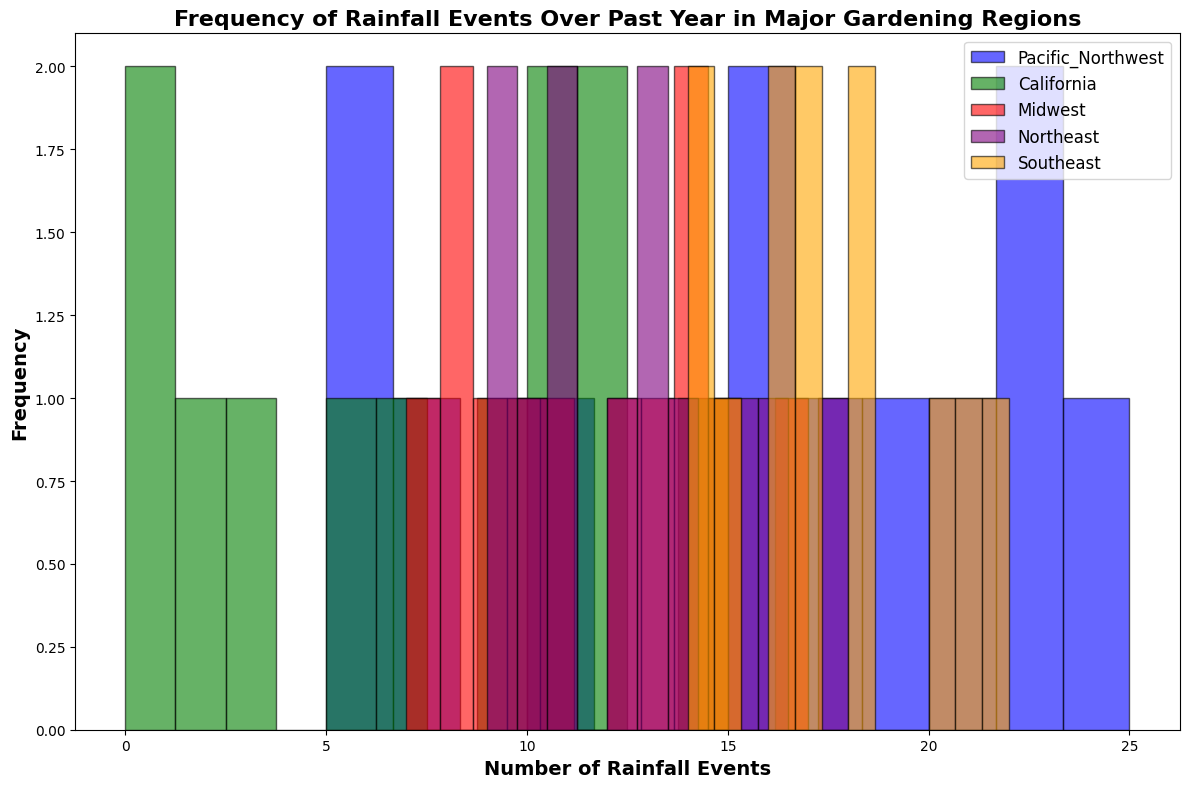What's the average frequency of rainfall events in the Pacific Northwest? To find the average, sum up all the rainfall events in the Pacific Northwest and divide by 12 (number of months). The sum is 20 + 18 + 22 + 19 + 15 + 10 + 5 + 6 + 8 + 16 + 22 + 25 = 186. The average is 186 / 12 = 15.5.
Answer: 15.5 Which region has the highest number of rainfall events in December? By comparing the bars representing December for each region, the Pacific Northwest has the highest at 25 events.
Answer: Pacific Northwest Are there more rainfall events in the Pacific Northwest in May or in California in March? Comparing the two bars visually, Pacific Northwest in May has 15 events and California in March has 15 events as well.
Answer: Equal Which region has the most consistent frequency of rainfall events throughout the year? The Midwest has relatively stable heights of bars compared to other regions, indicating more consistent monthly rainfall distribution.
Answer: Midwest How does the frequency of rainfall in the Southeast in April compare to the Northeast in June? Comparing the heights of the bars, the Southeast in April has 20 events, and the Northeast in June has 16 events. The Southeast has more.
Answer: Southeast What is the difference in the number of rainfall events between the Pacific Northwest in August and California in August? The Pacific Northwest has 6 events in August, while California has 0 events. The difference is 6 - 0 = 6.
Answer: 6 Which month had the most rainfall events in California? The tallest bar for California corresponds to January and December, both with 12 events.
Answer: January and December In which region does July have the least rainfall events? Comparing the July bars, California has the least with 1 event.
Answer: California What's the sum of rainfall events in the Midwest for the months of May and June? Adding the totals for May (14) and June (17), the sum is 14 + 17 = 31.
Answer: 31 Which region experienced a decrease in rainfall events from March to April? Pacific Northwest (22 to 19), California (15 to 9), Midwest (11 to 12 - this is an increase), Northeast (13 to 15 - this is an increase), and Southeast (18 to 20 - this is an increase). Thus, only Pacific Northwest and California experienced a decrease.
Answer: Pacific Northwest and California 